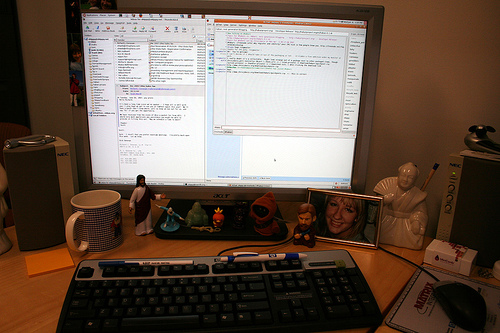<image>
Can you confirm if the jesus is behind the buddha? No. The jesus is not behind the buddha. From this viewpoint, the jesus appears to be positioned elsewhere in the scene. Is the keyboard in front of the mug? Yes. The keyboard is positioned in front of the mug, appearing closer to the camera viewpoint. Where is the frame in relation to the jesus? Is it in front of the jesus? No. The frame is not in front of the jesus. The spatial positioning shows a different relationship between these objects. 